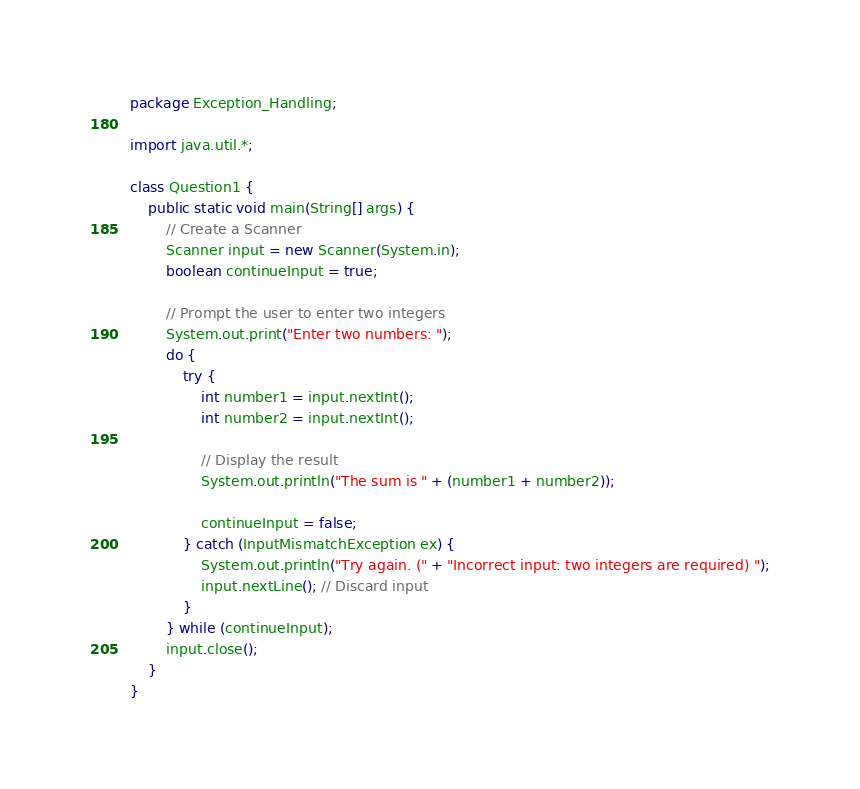<code> <loc_0><loc_0><loc_500><loc_500><_Java_>package Exception_Handling;

import java.util.*;

class Question1 {
    public static void main(String[] args) {
        // Create a Scanner
        Scanner input = new Scanner(System.in);
        boolean continueInput = true;

        // Prompt the user to enter two integers
        System.out.print("Enter two numbers: ");
        do {
            try {
                int number1 = input.nextInt();
                int number2 = input.nextInt();

                // Display the result
                System.out.println("The sum is " + (number1 + number2));

                continueInput = false;
            } catch (InputMismatchException ex) {
                System.out.println("Try again. (" + "Incorrect input: two integers are required) ");
                input.nextLine(); // Discard input
            }
        } while (continueInput);
        input.close();
    }
}</code> 